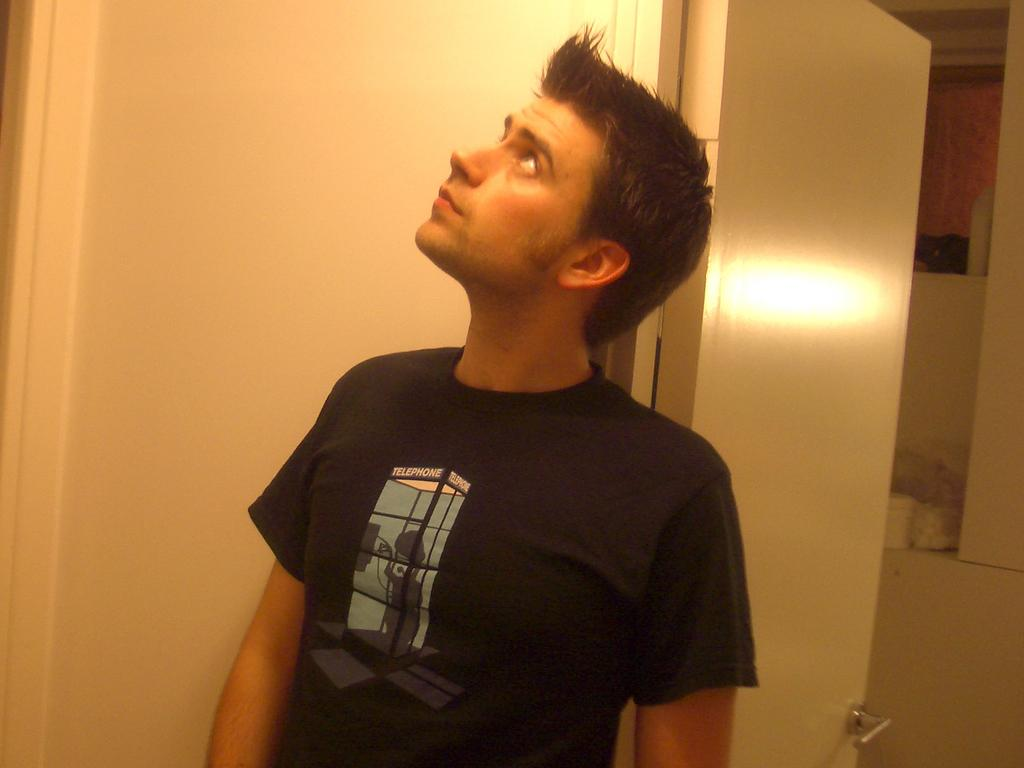What is present in the image? There is a person and an open door in the image. Can you describe the person in the image? The provided facts do not give any details about the person's appearance or clothing. What can be seen through the open door in the image? The facts do not specify what can be seen through the open door. What type of yarn is the person using to measure the distance between the door and the wall in the image? There is no yarn or measuring activity present in the image. 